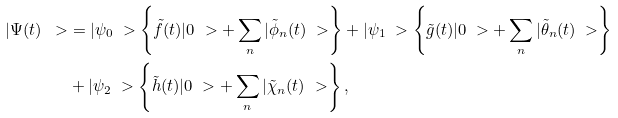Convert formula to latex. <formula><loc_0><loc_0><loc_500><loc_500>| \Psi ( t ) \ > & = | \psi _ { 0 } \ > \left \{ \tilde { f } ( t ) | 0 \ > + \sum _ { n } | \tilde { \phi } _ { n } ( t ) \ > \right \} + | \psi _ { 1 } \ > \left \{ \tilde { g } ( t ) | 0 \ > + \sum _ { n } | \tilde { \theta } _ { n } ( t ) \ > \right \} \\ & + | \psi _ { 2 } \ > \left \{ \tilde { h } ( t ) | 0 \ > + \sum _ { n } | \tilde { \chi } _ { n } ( t ) \ > \right \} ,</formula> 